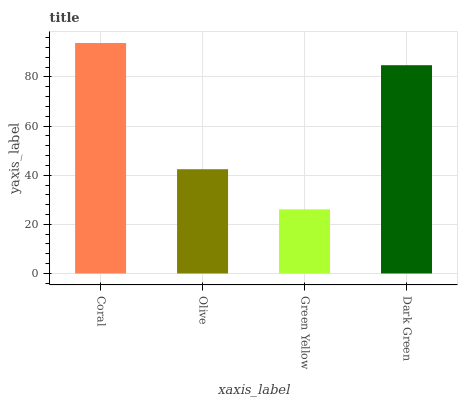Is Green Yellow the minimum?
Answer yes or no. Yes. Is Coral the maximum?
Answer yes or no. Yes. Is Olive the minimum?
Answer yes or no. No. Is Olive the maximum?
Answer yes or no. No. Is Coral greater than Olive?
Answer yes or no. Yes. Is Olive less than Coral?
Answer yes or no. Yes. Is Olive greater than Coral?
Answer yes or no. No. Is Coral less than Olive?
Answer yes or no. No. Is Dark Green the high median?
Answer yes or no. Yes. Is Olive the low median?
Answer yes or no. Yes. Is Coral the high median?
Answer yes or no. No. Is Coral the low median?
Answer yes or no. No. 